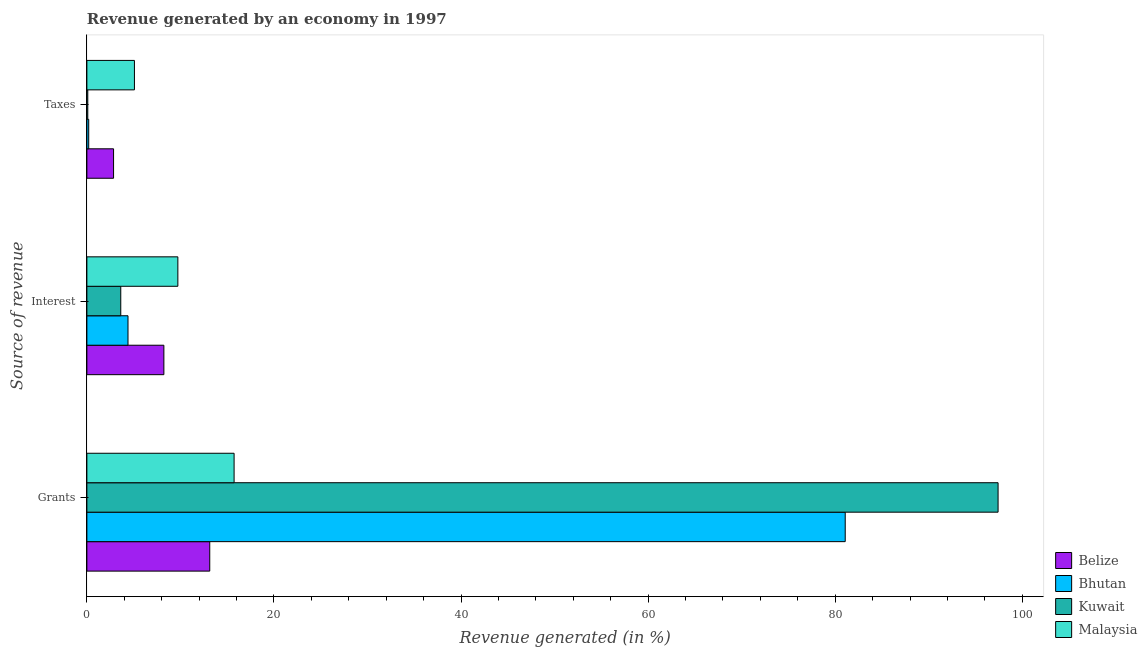How many different coloured bars are there?
Provide a short and direct response. 4. Are the number of bars per tick equal to the number of legend labels?
Ensure brevity in your answer.  Yes. What is the label of the 2nd group of bars from the top?
Keep it short and to the point. Interest. What is the percentage of revenue generated by taxes in Kuwait?
Offer a very short reply. 0.1. Across all countries, what is the maximum percentage of revenue generated by taxes?
Ensure brevity in your answer.  5.08. Across all countries, what is the minimum percentage of revenue generated by grants?
Your answer should be very brief. 13.14. In which country was the percentage of revenue generated by taxes maximum?
Offer a terse response. Malaysia. In which country was the percentage of revenue generated by taxes minimum?
Your response must be concise. Kuwait. What is the total percentage of revenue generated by grants in the graph?
Provide a short and direct response. 207.35. What is the difference between the percentage of revenue generated by taxes in Bhutan and that in Belize?
Provide a succinct answer. -2.66. What is the difference between the percentage of revenue generated by grants in Belize and the percentage of revenue generated by interest in Kuwait?
Give a very brief answer. 9.51. What is the average percentage of revenue generated by interest per country?
Give a very brief answer. 6.49. What is the difference between the percentage of revenue generated by taxes and percentage of revenue generated by grants in Malaysia?
Offer a terse response. -10.65. In how many countries, is the percentage of revenue generated by grants greater than 68 %?
Your response must be concise. 2. What is the ratio of the percentage of revenue generated by taxes in Malaysia to that in Kuwait?
Your answer should be very brief. 52.98. Is the percentage of revenue generated by grants in Bhutan less than that in Kuwait?
Give a very brief answer. Yes. Is the difference between the percentage of revenue generated by taxes in Kuwait and Malaysia greater than the difference between the percentage of revenue generated by interest in Kuwait and Malaysia?
Provide a succinct answer. Yes. What is the difference between the highest and the second highest percentage of revenue generated by interest?
Your answer should be very brief. 1.49. What is the difference between the highest and the lowest percentage of revenue generated by interest?
Keep it short and to the point. 6.1. What does the 4th bar from the top in Taxes represents?
Give a very brief answer. Belize. What does the 2nd bar from the bottom in Interest represents?
Offer a very short reply. Bhutan. Are all the bars in the graph horizontal?
Provide a succinct answer. Yes. What is the difference between two consecutive major ticks on the X-axis?
Provide a short and direct response. 20. Are the values on the major ticks of X-axis written in scientific E-notation?
Provide a succinct answer. No. Does the graph contain grids?
Give a very brief answer. No. How many legend labels are there?
Your response must be concise. 4. How are the legend labels stacked?
Offer a very short reply. Vertical. What is the title of the graph?
Ensure brevity in your answer.  Revenue generated by an economy in 1997. What is the label or title of the X-axis?
Give a very brief answer. Revenue generated (in %). What is the label or title of the Y-axis?
Ensure brevity in your answer.  Source of revenue. What is the Revenue generated (in %) of Belize in Grants?
Provide a succinct answer. 13.14. What is the Revenue generated (in %) in Bhutan in Grants?
Your answer should be very brief. 81.07. What is the Revenue generated (in %) of Kuwait in Grants?
Provide a succinct answer. 97.41. What is the Revenue generated (in %) of Malaysia in Grants?
Make the answer very short. 15.74. What is the Revenue generated (in %) in Belize in Interest?
Offer a very short reply. 8.23. What is the Revenue generated (in %) in Bhutan in Interest?
Ensure brevity in your answer.  4.4. What is the Revenue generated (in %) in Kuwait in Interest?
Your answer should be very brief. 3.62. What is the Revenue generated (in %) in Malaysia in Interest?
Keep it short and to the point. 9.73. What is the Revenue generated (in %) of Belize in Taxes?
Give a very brief answer. 2.85. What is the Revenue generated (in %) in Bhutan in Taxes?
Offer a very short reply. 0.2. What is the Revenue generated (in %) of Kuwait in Taxes?
Make the answer very short. 0.1. What is the Revenue generated (in %) of Malaysia in Taxes?
Provide a succinct answer. 5.08. Across all Source of revenue, what is the maximum Revenue generated (in %) of Belize?
Your answer should be very brief. 13.14. Across all Source of revenue, what is the maximum Revenue generated (in %) of Bhutan?
Make the answer very short. 81.07. Across all Source of revenue, what is the maximum Revenue generated (in %) in Kuwait?
Your response must be concise. 97.41. Across all Source of revenue, what is the maximum Revenue generated (in %) in Malaysia?
Your answer should be compact. 15.74. Across all Source of revenue, what is the minimum Revenue generated (in %) of Belize?
Your answer should be very brief. 2.85. Across all Source of revenue, what is the minimum Revenue generated (in %) of Bhutan?
Offer a terse response. 0.2. Across all Source of revenue, what is the minimum Revenue generated (in %) of Kuwait?
Provide a short and direct response. 0.1. Across all Source of revenue, what is the minimum Revenue generated (in %) in Malaysia?
Ensure brevity in your answer.  5.08. What is the total Revenue generated (in %) of Belize in the graph?
Offer a terse response. 24.22. What is the total Revenue generated (in %) in Bhutan in the graph?
Ensure brevity in your answer.  85.66. What is the total Revenue generated (in %) of Kuwait in the graph?
Provide a short and direct response. 101.13. What is the total Revenue generated (in %) of Malaysia in the graph?
Provide a short and direct response. 30.55. What is the difference between the Revenue generated (in %) of Belize in Grants and that in Interest?
Offer a very short reply. 4.9. What is the difference between the Revenue generated (in %) in Bhutan in Grants and that in Interest?
Keep it short and to the point. 76.67. What is the difference between the Revenue generated (in %) of Kuwait in Grants and that in Interest?
Provide a succinct answer. 93.79. What is the difference between the Revenue generated (in %) of Malaysia in Grants and that in Interest?
Offer a terse response. 6.01. What is the difference between the Revenue generated (in %) in Belize in Grants and that in Taxes?
Offer a terse response. 10.28. What is the difference between the Revenue generated (in %) of Bhutan in Grants and that in Taxes?
Provide a short and direct response. 80.87. What is the difference between the Revenue generated (in %) in Kuwait in Grants and that in Taxes?
Make the answer very short. 97.31. What is the difference between the Revenue generated (in %) in Malaysia in Grants and that in Taxes?
Ensure brevity in your answer.  10.65. What is the difference between the Revenue generated (in %) in Belize in Interest and that in Taxes?
Your response must be concise. 5.38. What is the difference between the Revenue generated (in %) in Bhutan in Interest and that in Taxes?
Keep it short and to the point. 4.2. What is the difference between the Revenue generated (in %) in Kuwait in Interest and that in Taxes?
Keep it short and to the point. 3.53. What is the difference between the Revenue generated (in %) of Malaysia in Interest and that in Taxes?
Your answer should be compact. 4.64. What is the difference between the Revenue generated (in %) in Belize in Grants and the Revenue generated (in %) in Bhutan in Interest?
Provide a short and direct response. 8.74. What is the difference between the Revenue generated (in %) in Belize in Grants and the Revenue generated (in %) in Kuwait in Interest?
Offer a very short reply. 9.51. What is the difference between the Revenue generated (in %) of Belize in Grants and the Revenue generated (in %) of Malaysia in Interest?
Give a very brief answer. 3.41. What is the difference between the Revenue generated (in %) in Bhutan in Grants and the Revenue generated (in %) in Kuwait in Interest?
Provide a short and direct response. 77.45. What is the difference between the Revenue generated (in %) in Bhutan in Grants and the Revenue generated (in %) in Malaysia in Interest?
Give a very brief answer. 71.34. What is the difference between the Revenue generated (in %) in Kuwait in Grants and the Revenue generated (in %) in Malaysia in Interest?
Your answer should be very brief. 87.68. What is the difference between the Revenue generated (in %) of Belize in Grants and the Revenue generated (in %) of Bhutan in Taxes?
Provide a succinct answer. 12.94. What is the difference between the Revenue generated (in %) in Belize in Grants and the Revenue generated (in %) in Kuwait in Taxes?
Your answer should be compact. 13.04. What is the difference between the Revenue generated (in %) of Belize in Grants and the Revenue generated (in %) of Malaysia in Taxes?
Offer a very short reply. 8.05. What is the difference between the Revenue generated (in %) in Bhutan in Grants and the Revenue generated (in %) in Kuwait in Taxes?
Provide a succinct answer. 80.97. What is the difference between the Revenue generated (in %) of Bhutan in Grants and the Revenue generated (in %) of Malaysia in Taxes?
Ensure brevity in your answer.  75.98. What is the difference between the Revenue generated (in %) in Kuwait in Grants and the Revenue generated (in %) in Malaysia in Taxes?
Offer a very short reply. 92.32. What is the difference between the Revenue generated (in %) of Belize in Interest and the Revenue generated (in %) of Bhutan in Taxes?
Your response must be concise. 8.04. What is the difference between the Revenue generated (in %) of Belize in Interest and the Revenue generated (in %) of Kuwait in Taxes?
Offer a very short reply. 8.14. What is the difference between the Revenue generated (in %) of Belize in Interest and the Revenue generated (in %) of Malaysia in Taxes?
Provide a succinct answer. 3.15. What is the difference between the Revenue generated (in %) of Bhutan in Interest and the Revenue generated (in %) of Kuwait in Taxes?
Your answer should be very brief. 4.3. What is the difference between the Revenue generated (in %) in Bhutan in Interest and the Revenue generated (in %) in Malaysia in Taxes?
Provide a succinct answer. -0.69. What is the difference between the Revenue generated (in %) in Kuwait in Interest and the Revenue generated (in %) in Malaysia in Taxes?
Your answer should be compact. -1.46. What is the average Revenue generated (in %) of Belize per Source of revenue?
Give a very brief answer. 8.07. What is the average Revenue generated (in %) in Bhutan per Source of revenue?
Your answer should be very brief. 28.55. What is the average Revenue generated (in %) in Kuwait per Source of revenue?
Give a very brief answer. 33.71. What is the average Revenue generated (in %) in Malaysia per Source of revenue?
Make the answer very short. 10.18. What is the difference between the Revenue generated (in %) of Belize and Revenue generated (in %) of Bhutan in Grants?
Make the answer very short. -67.93. What is the difference between the Revenue generated (in %) of Belize and Revenue generated (in %) of Kuwait in Grants?
Your answer should be very brief. -84.27. What is the difference between the Revenue generated (in %) of Belize and Revenue generated (in %) of Malaysia in Grants?
Ensure brevity in your answer.  -2.6. What is the difference between the Revenue generated (in %) in Bhutan and Revenue generated (in %) in Kuwait in Grants?
Provide a short and direct response. -16.34. What is the difference between the Revenue generated (in %) in Bhutan and Revenue generated (in %) in Malaysia in Grants?
Provide a short and direct response. 65.33. What is the difference between the Revenue generated (in %) in Kuwait and Revenue generated (in %) in Malaysia in Grants?
Give a very brief answer. 81.67. What is the difference between the Revenue generated (in %) of Belize and Revenue generated (in %) of Bhutan in Interest?
Ensure brevity in your answer.  3.83. What is the difference between the Revenue generated (in %) in Belize and Revenue generated (in %) in Kuwait in Interest?
Your response must be concise. 4.61. What is the difference between the Revenue generated (in %) in Belize and Revenue generated (in %) in Malaysia in Interest?
Your response must be concise. -1.49. What is the difference between the Revenue generated (in %) of Bhutan and Revenue generated (in %) of Kuwait in Interest?
Ensure brevity in your answer.  0.77. What is the difference between the Revenue generated (in %) in Bhutan and Revenue generated (in %) in Malaysia in Interest?
Ensure brevity in your answer.  -5.33. What is the difference between the Revenue generated (in %) of Kuwait and Revenue generated (in %) of Malaysia in Interest?
Give a very brief answer. -6.1. What is the difference between the Revenue generated (in %) in Belize and Revenue generated (in %) in Bhutan in Taxes?
Provide a succinct answer. 2.66. What is the difference between the Revenue generated (in %) of Belize and Revenue generated (in %) of Kuwait in Taxes?
Make the answer very short. 2.76. What is the difference between the Revenue generated (in %) in Belize and Revenue generated (in %) in Malaysia in Taxes?
Your response must be concise. -2.23. What is the difference between the Revenue generated (in %) in Bhutan and Revenue generated (in %) in Kuwait in Taxes?
Your response must be concise. 0.1. What is the difference between the Revenue generated (in %) in Bhutan and Revenue generated (in %) in Malaysia in Taxes?
Offer a terse response. -4.89. What is the difference between the Revenue generated (in %) in Kuwait and Revenue generated (in %) in Malaysia in Taxes?
Keep it short and to the point. -4.99. What is the ratio of the Revenue generated (in %) in Belize in Grants to that in Interest?
Provide a succinct answer. 1.6. What is the ratio of the Revenue generated (in %) of Bhutan in Grants to that in Interest?
Offer a terse response. 18.44. What is the ratio of the Revenue generated (in %) in Kuwait in Grants to that in Interest?
Your answer should be compact. 26.89. What is the ratio of the Revenue generated (in %) in Malaysia in Grants to that in Interest?
Your answer should be very brief. 1.62. What is the ratio of the Revenue generated (in %) in Belize in Grants to that in Taxes?
Ensure brevity in your answer.  4.6. What is the ratio of the Revenue generated (in %) in Bhutan in Grants to that in Taxes?
Provide a short and direct response. 413.43. What is the ratio of the Revenue generated (in %) in Kuwait in Grants to that in Taxes?
Your response must be concise. 1015. What is the ratio of the Revenue generated (in %) in Malaysia in Grants to that in Taxes?
Offer a terse response. 3.1. What is the ratio of the Revenue generated (in %) of Belize in Interest to that in Taxes?
Your answer should be compact. 2.88. What is the ratio of the Revenue generated (in %) in Bhutan in Interest to that in Taxes?
Provide a succinct answer. 22.42. What is the ratio of the Revenue generated (in %) of Kuwait in Interest to that in Taxes?
Give a very brief answer. 37.75. What is the ratio of the Revenue generated (in %) of Malaysia in Interest to that in Taxes?
Make the answer very short. 1.91. What is the difference between the highest and the second highest Revenue generated (in %) of Belize?
Your response must be concise. 4.9. What is the difference between the highest and the second highest Revenue generated (in %) of Bhutan?
Provide a succinct answer. 76.67. What is the difference between the highest and the second highest Revenue generated (in %) in Kuwait?
Give a very brief answer. 93.79. What is the difference between the highest and the second highest Revenue generated (in %) of Malaysia?
Provide a short and direct response. 6.01. What is the difference between the highest and the lowest Revenue generated (in %) in Belize?
Keep it short and to the point. 10.28. What is the difference between the highest and the lowest Revenue generated (in %) of Bhutan?
Provide a succinct answer. 80.87. What is the difference between the highest and the lowest Revenue generated (in %) of Kuwait?
Make the answer very short. 97.31. What is the difference between the highest and the lowest Revenue generated (in %) in Malaysia?
Make the answer very short. 10.65. 